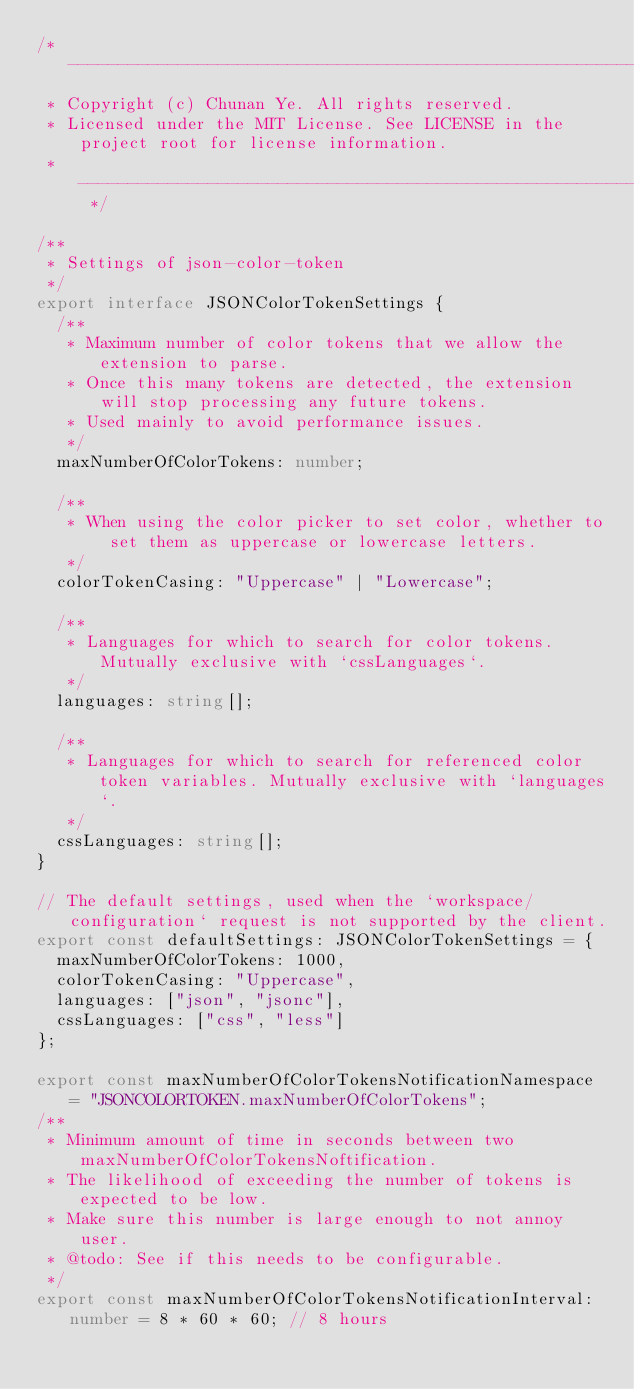Convert code to text. <code><loc_0><loc_0><loc_500><loc_500><_TypeScript_>/* --------------------------------------------------------------------------------------------
 * Copyright (c) Chunan Ye. All rights reserved.
 * Licensed under the MIT License. See LICENSE in the project root for license information.
 * ------------------------------------------------------------------------------------------ */

/**
 * Settings of json-color-token
 */
export interface JSONColorTokenSettings {
	/**
	 * Maximum number of color tokens that we allow the extension to parse.
	 * Once this many tokens are detected, the extension will stop processing any future tokens.
	 * Used mainly to avoid performance issues.
	 */
	maxNumberOfColorTokens: number;

	/**
	 * When using the color picker to set color, whether to set them as uppercase or lowercase letters.
	 */
	colorTokenCasing: "Uppercase" | "Lowercase";

	/**
	 * Languages for which to search for color tokens. Mutually exclusive with `cssLanguages`.
	 */
	languages: string[];

	/**
	 * Languages for which to search for referenced color token variables. Mutually exclusive with `languages`.
	 */
	cssLanguages: string[];
}

// The default settings, used when the `workspace/configuration` request is not supported by the client.
export const defaultSettings: JSONColorTokenSettings = {
	maxNumberOfColorTokens: 1000,
	colorTokenCasing: "Uppercase",
	languages: ["json", "jsonc"],
	cssLanguages: ["css", "less"]
};

export const maxNumberOfColorTokensNotificationNamespace = "JSONCOLORTOKEN.maxNumberOfColorTokens";
/**
 * Minimum amount of time in seconds between two maxNumberOfColorTokensNoftification.
 * The likelihood of exceeding the number of tokens is expected to be low.
 * Make sure this number is large enough to not annoy user.
 * @todo: See if this needs to be configurable.
 */
export const maxNumberOfColorTokensNotificationInterval: number = 8 * 60 * 60; // 8 hours
</code> 